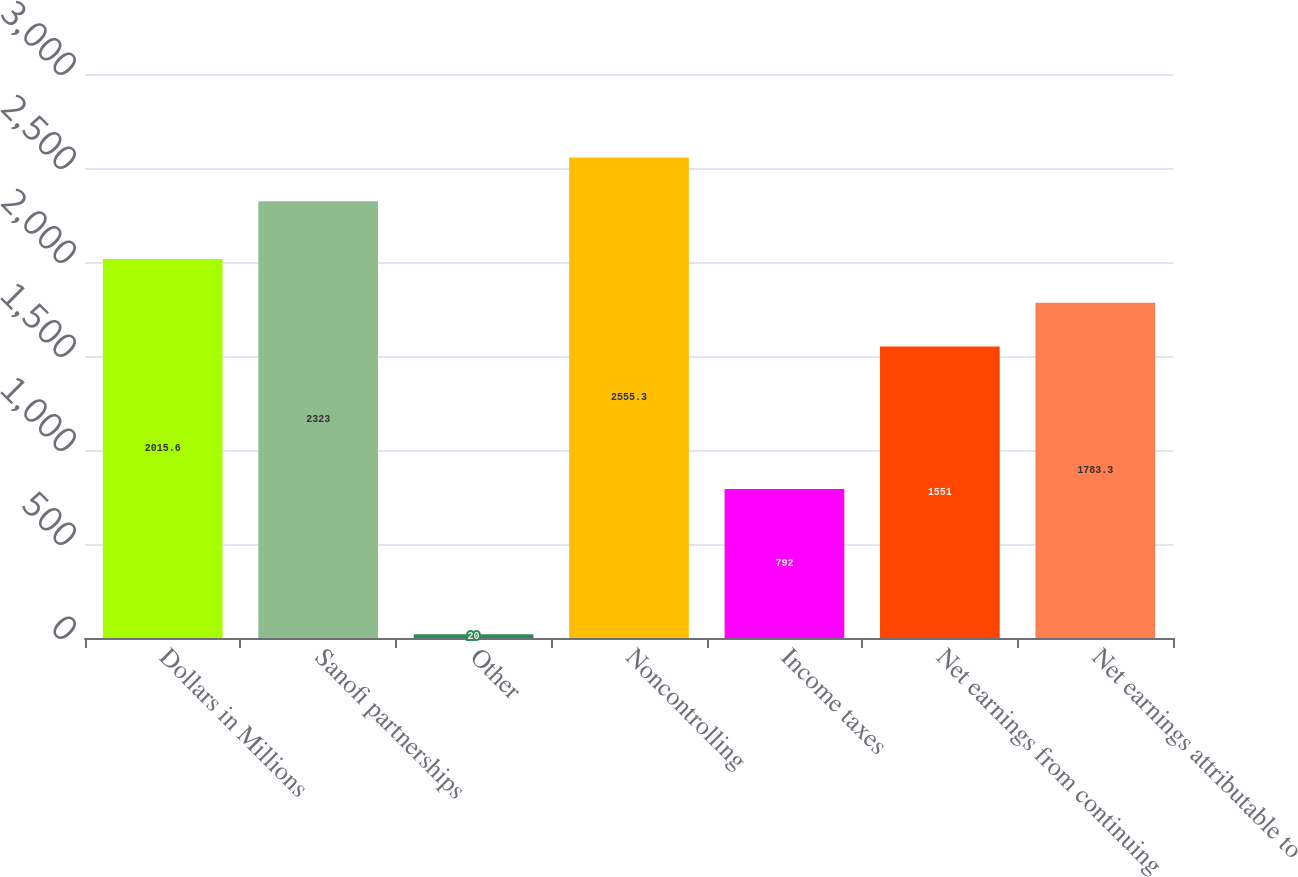Convert chart. <chart><loc_0><loc_0><loc_500><loc_500><bar_chart><fcel>Dollars in Millions<fcel>Sanofi partnerships<fcel>Other<fcel>Noncontrolling<fcel>Income taxes<fcel>Net earnings from continuing<fcel>Net earnings attributable to<nl><fcel>2015.6<fcel>2323<fcel>20<fcel>2555.3<fcel>792<fcel>1551<fcel>1783.3<nl></chart> 